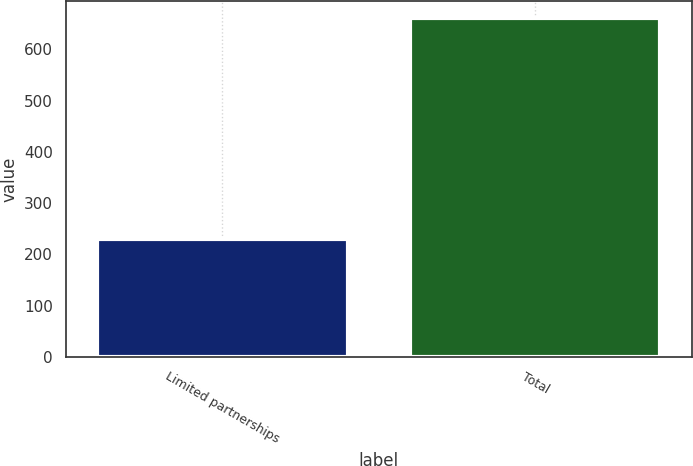<chart> <loc_0><loc_0><loc_500><loc_500><bar_chart><fcel>Limited partnerships<fcel>Total<nl><fcel>230<fcel>661<nl></chart> 